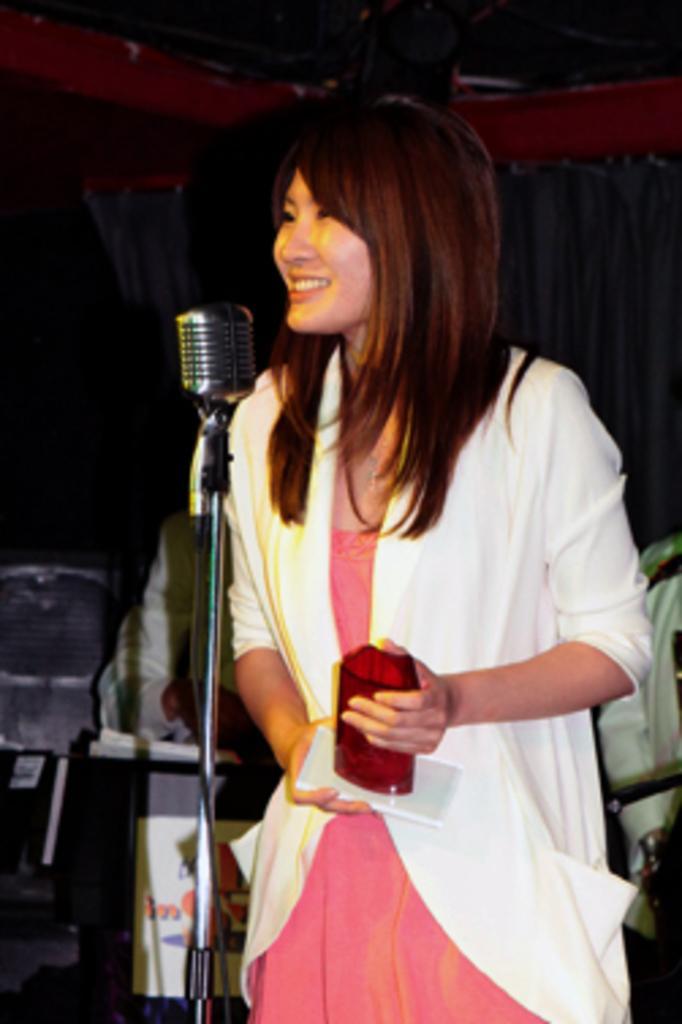Could you give a brief overview of what you see in this image? In the center of the image there is a woman standing at the mic. In the background we can see persons, curtain and wall. 